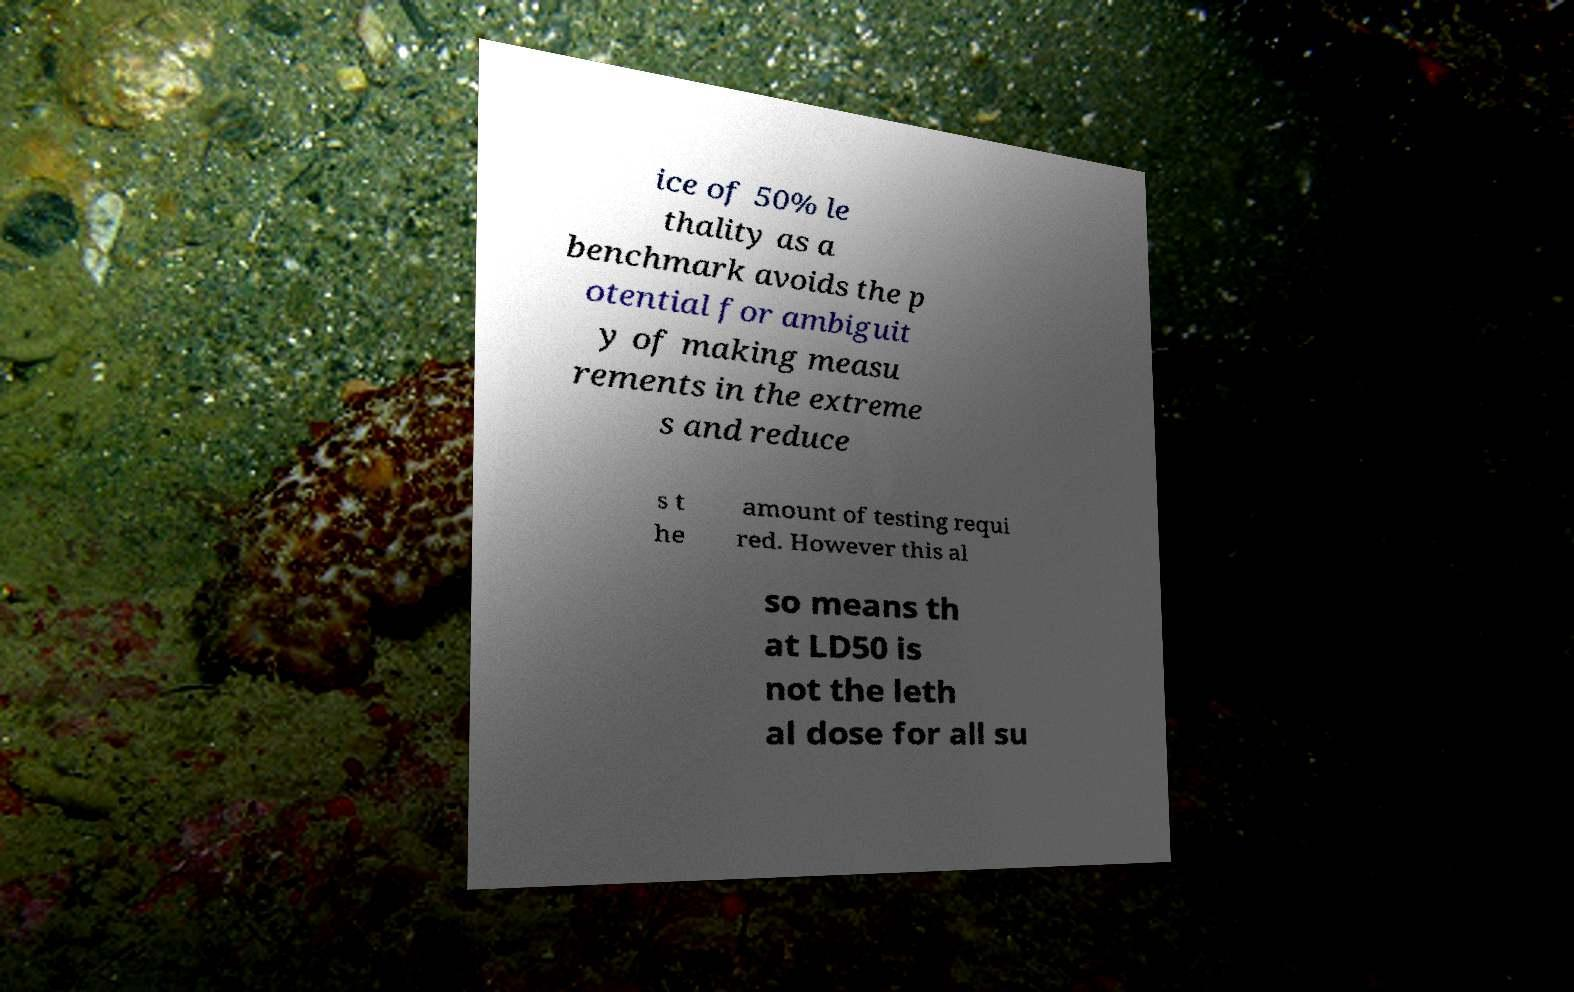Can you accurately transcribe the text from the provided image for me? ice of 50% le thality as a benchmark avoids the p otential for ambiguit y of making measu rements in the extreme s and reduce s t he amount of testing requi red. However this al so means th at LD50 is not the leth al dose for all su 